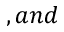<formula> <loc_0><loc_0><loc_500><loc_500>, a n d</formula> 